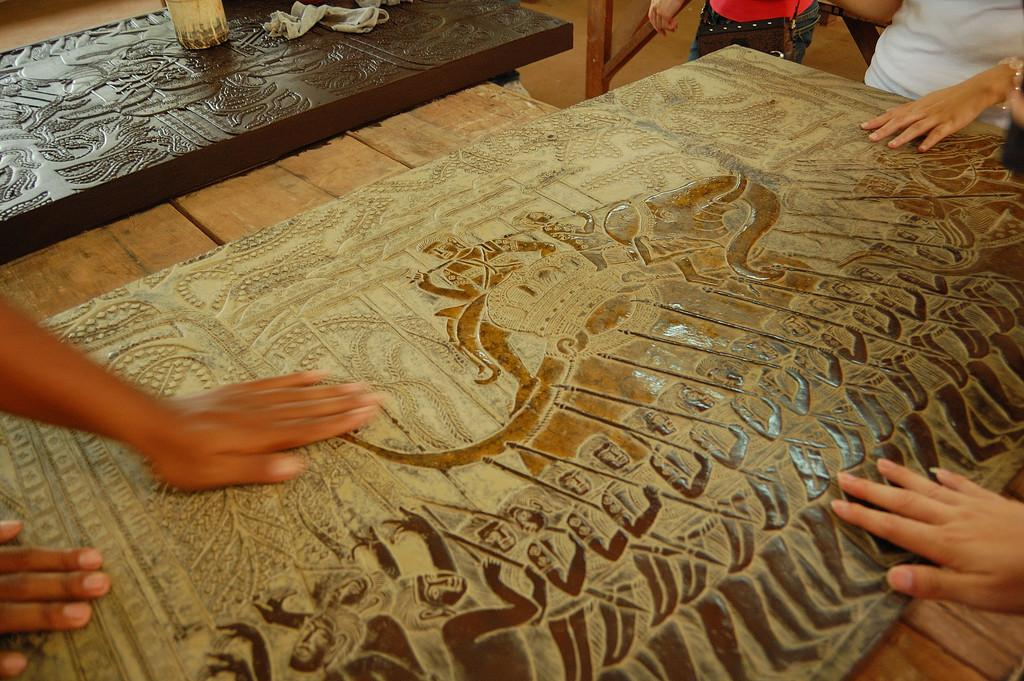What body parts are visible in the image? Human hands and fingers are visible in the image. What type of surface is present in the image? There is a wooden surface in the image. What material is covering the wooden surface? A metal sheet is present on the wooden surface. How many clovers can be seen growing on the wooden surface in the image? There are no clovers present in the image; it features human hands, a wooden surface, and a metal sheet. 